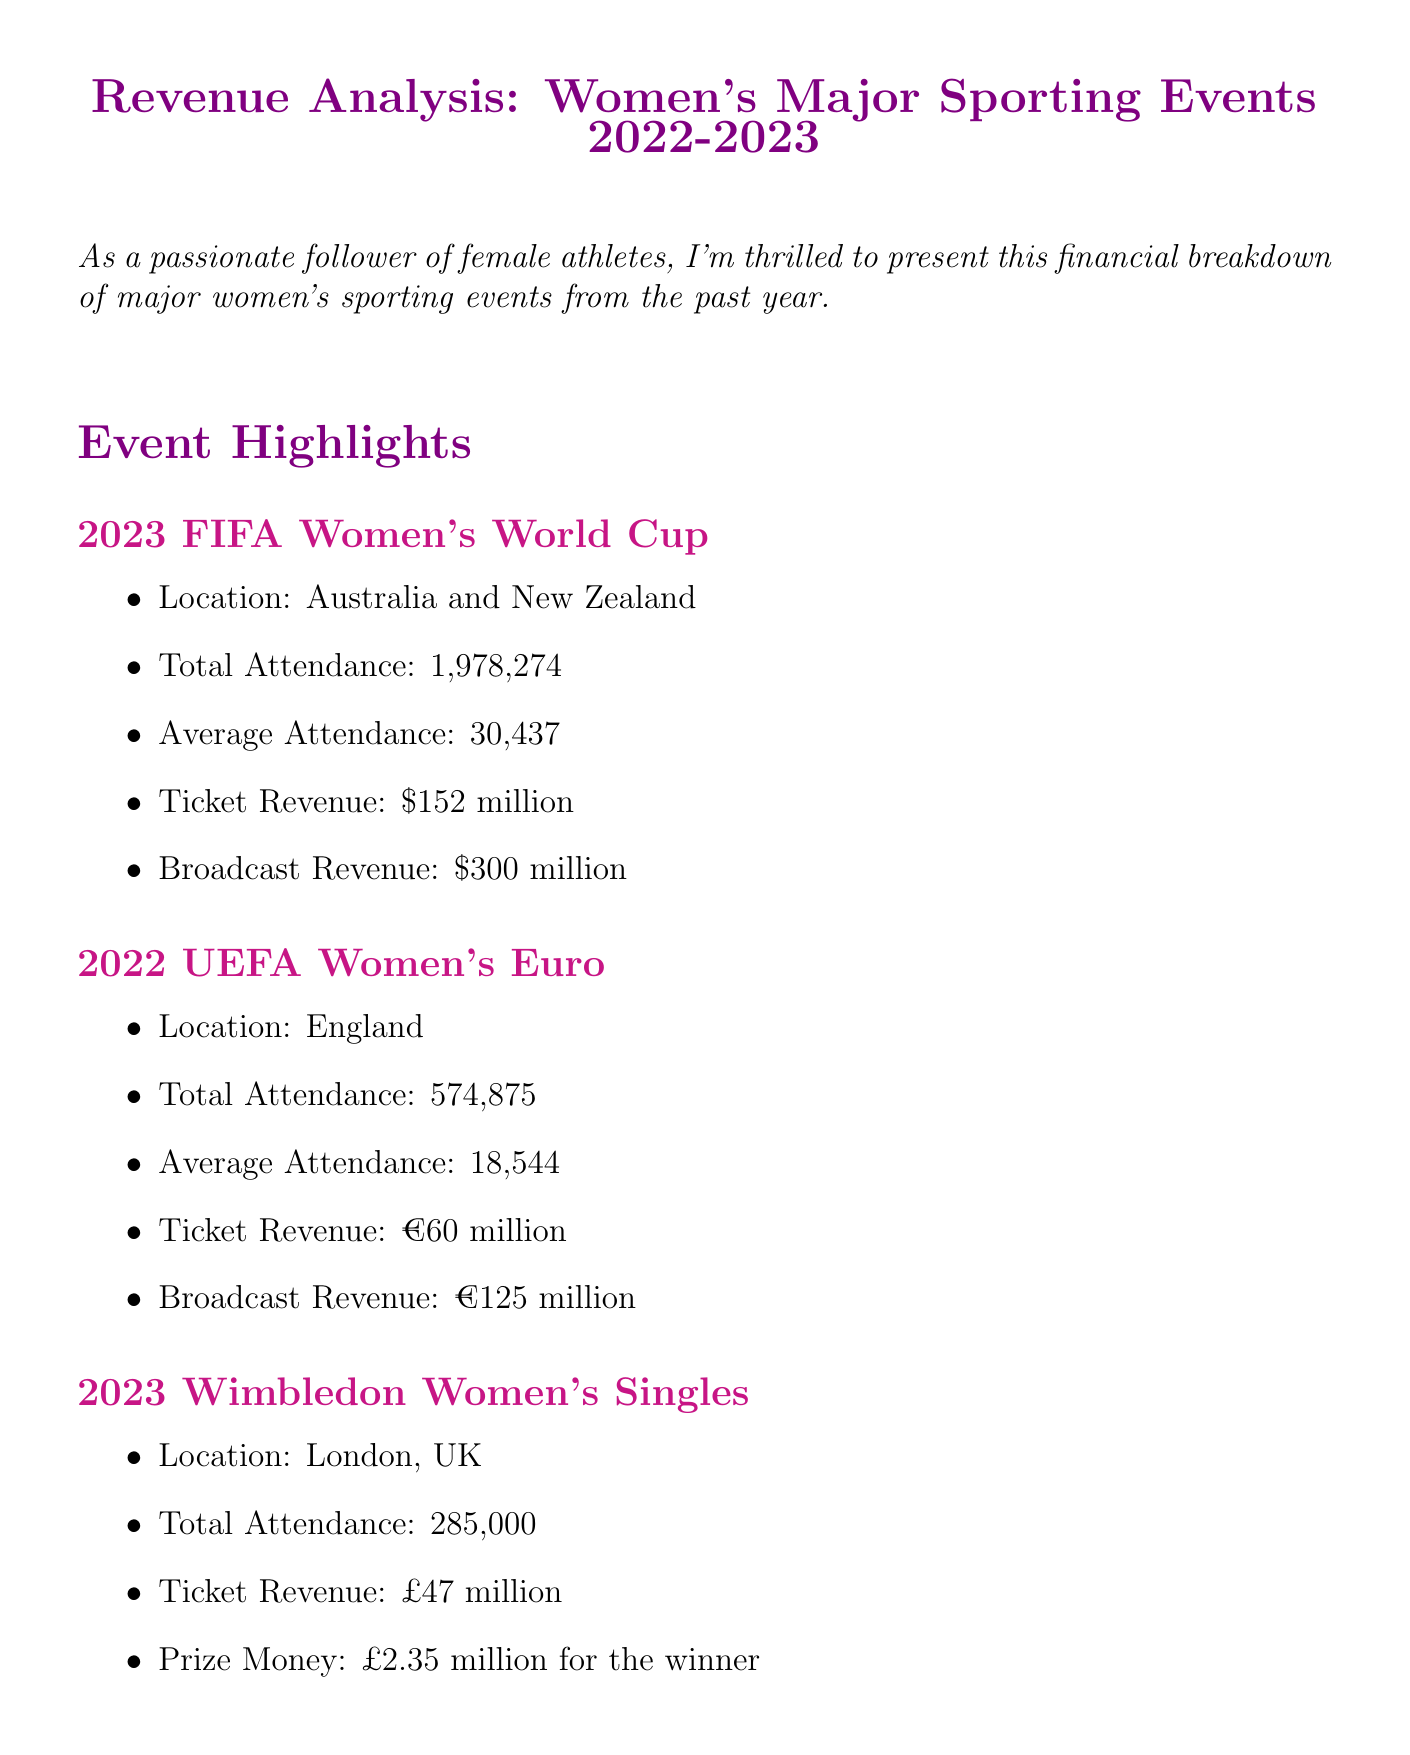What was the total attendance at the 2023 FIFA Women's World Cup? The total attendance for the 2023 FIFA Women's World Cup is provided in the document, which is 1,978,274.
Answer: 1,978,274 What was the broadcast revenue for the UEFA Women's Euro 2022? The document specifies that the broadcast revenue for the UEFA Women's Euro 2022 is €125 million.
Answer: €125 million How much was the ticket revenue for Wimbledon 2023? According to the document, the ticket revenue for Wimbledon 2023 is £47 million.
Answer: £47 million What percentage increase in attendance did the FIFA Women's World Cup experience compared to the 2019 edition? The document notes a 54% increase in attendance for the FIFA Women's World Cup compared to its 2019 version.
Answer: 54% Which event had the highest total attendance? By comparing the attendance figures in the document, it is clear that the 2023 FIFA Women's World Cup had the highest attendance.
Answer: 2023 FIFA Women's World Cup What is the total prize money for the winner of Wimbledon Women's Singles? The document states that the prize money for the winner of the Wimbledon Women's Singles is £2.35 million.
Answer: £2.35 million In which countries was the 2023 FIFA Women's World Cup held? The document indicates that the 2023 FIFA Women's World Cup took place in Australia and New Zealand.
Answer: Australia and New Zealand Which key finding highlights gender pay parity? The document mentions that Wimbledon achieved gender pay parity in 2007 as a key finding.
Answer: gender pay parity What was the average attendance for the UEFA Women's Euro 2022? The average attendance figure for the UEFA Women's Euro 2022 noted in the document is 18,544.
Answer: 18,544 